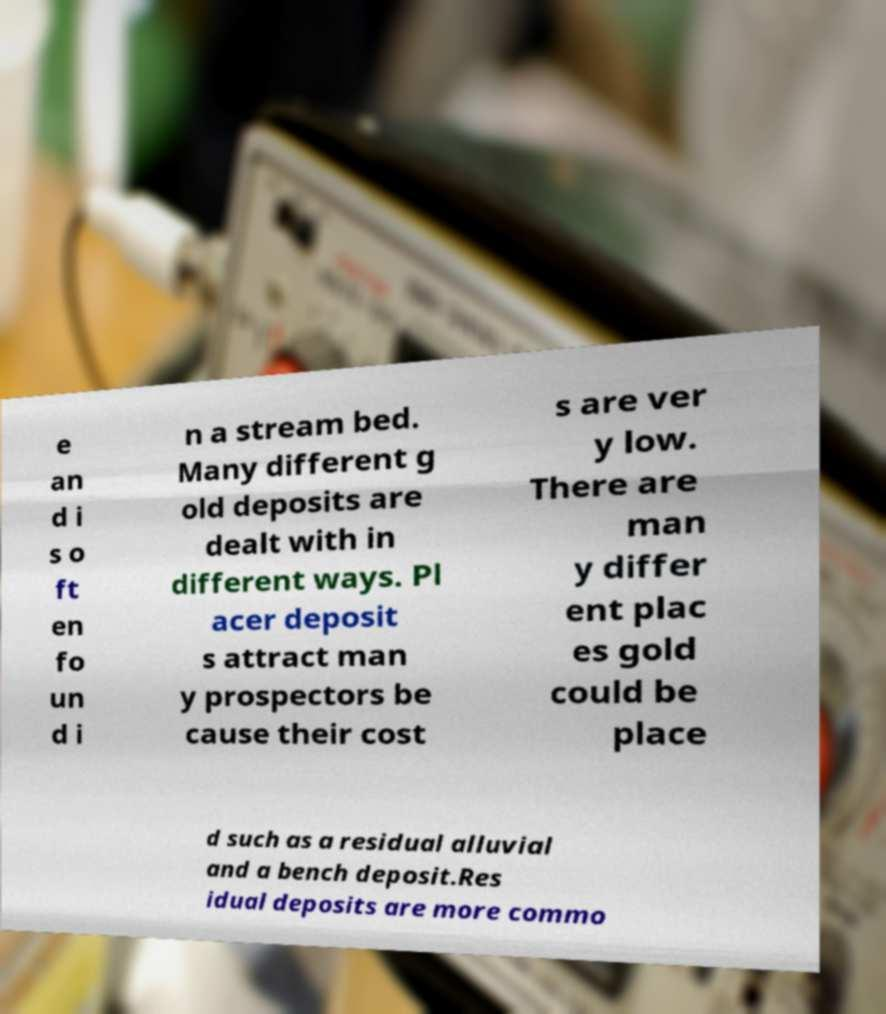Please identify and transcribe the text found in this image. e an d i s o ft en fo un d i n a stream bed. Many different g old deposits are dealt with in different ways. Pl acer deposit s attract man y prospectors be cause their cost s are ver y low. There are man y differ ent plac es gold could be place d such as a residual alluvial and a bench deposit.Res idual deposits are more commo 